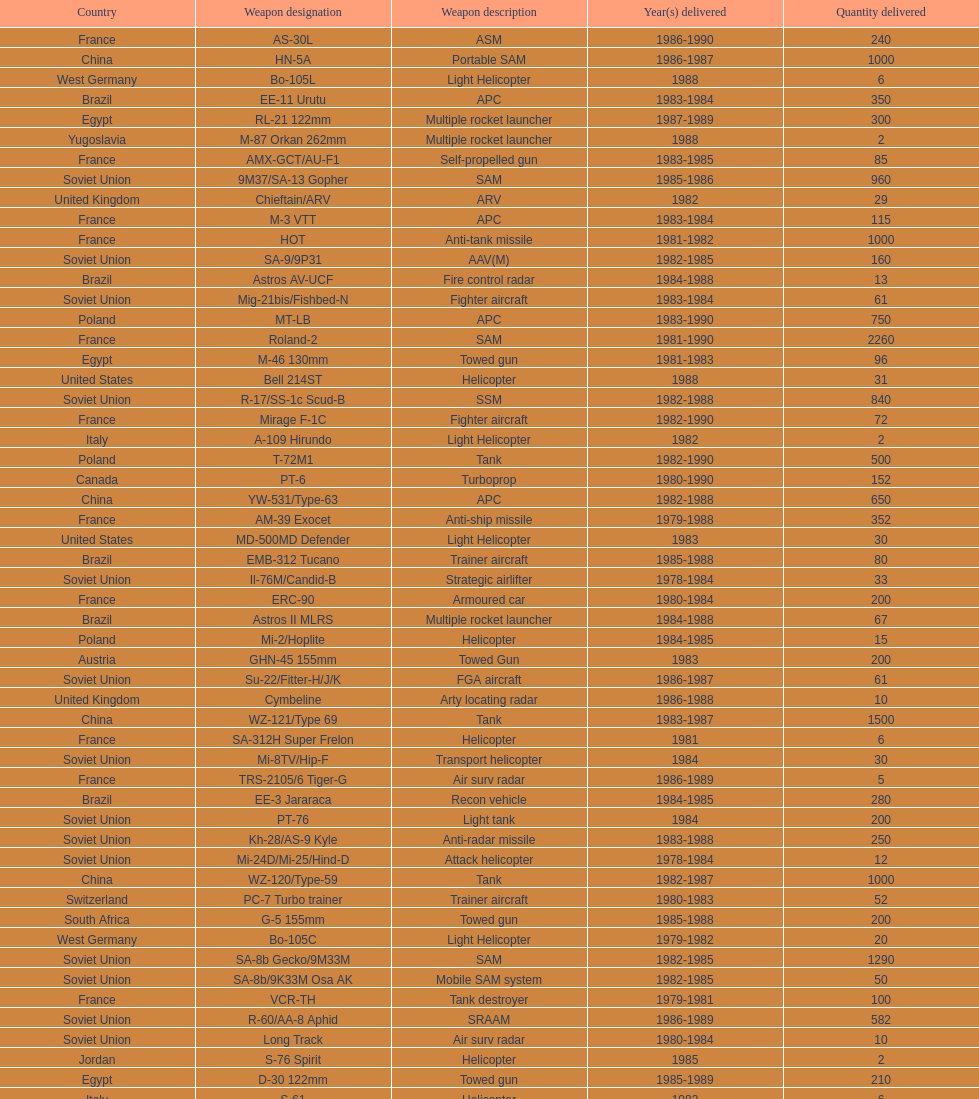What is the total number of tanks sold by china to iraq? 2500. 